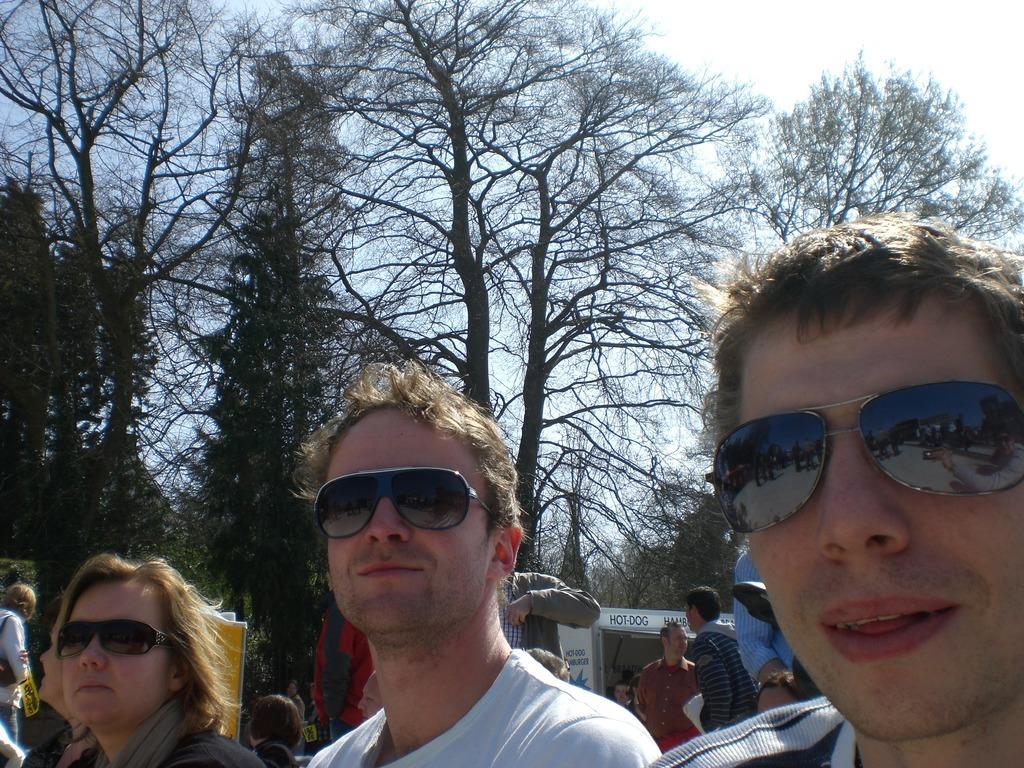How would you summarize this image in a sentence or two? In the picture I can see three persons wearing goggles and there are few other persons and trees in the background. 